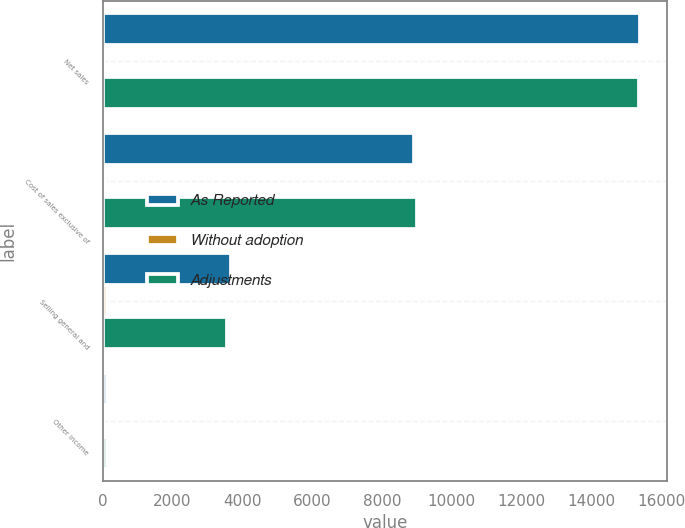Convert chart. <chart><loc_0><loc_0><loc_500><loc_500><stacked_bar_chart><ecel><fcel>Net sales<fcel>Cost of sales exclusive of<fcel>Selling general and<fcel>Other income<nl><fcel>As Reported<fcel>15399<fcel>8925<fcel>3682<fcel>122<nl><fcel>Without adoption<fcel>25<fcel>76<fcel>109<fcel>8<nl><fcel>Adjustments<fcel>15374<fcel>9001<fcel>3573<fcel>114<nl></chart> 